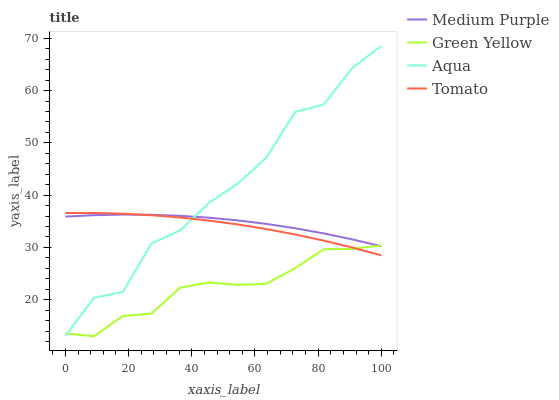Does Tomato have the minimum area under the curve?
Answer yes or no. No. Does Tomato have the maximum area under the curve?
Answer yes or no. No. Is Green Yellow the smoothest?
Answer yes or no. No. Is Green Yellow the roughest?
Answer yes or no. No. Does Tomato have the lowest value?
Answer yes or no. No. Does Tomato have the highest value?
Answer yes or no. No. 